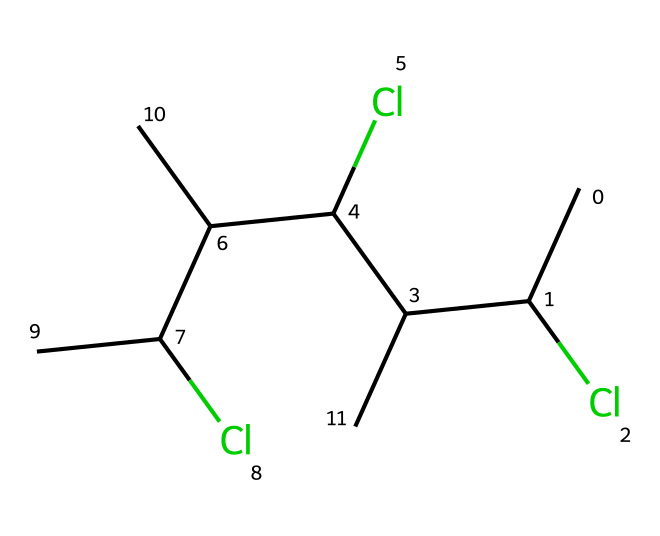How many carbon atoms are in this molecule? To determine the number of carbon atoms, we can analyze the SMILES representation, counting each 'C' that represents a carbon atom. The representation shows a total of six 'C' letters, indicating there are six carbon atoms in the molecule.
Answer: six How many chlorine atoms are present in the structure? In the SMILES representation, every 'Cl' indicates a chlorine atom. By counting the occurrences of 'Cl', we find three instances, which indicates there are three chlorine atoms in the molecule.
Answer: three What type of polymer is represented by this structure? The presence of multiple carbon atoms and chlorine substitution in the SMILES points towards it being a polyvinyl chloride. This polymer is commonly recognized for its use in construction materials and its vinyl groups result in PVC.
Answer: polyvinyl chloride How many total hydrogen atoms are associated with this molecule? To determine the total number of hydrogen atoms, we consider the valence requirements of carbon, which typically forms four bonds. Each carbon can bond with hydrogen to satisfy this; given the number of carbons and chlorines, we can deduce there are a total of eight hydrogen atoms in this structure.
Answer: eight What functional groups are indicated by the presence of chlorine in this compound? The chlorine substituents indicate that this compound contains alkyl groups that have been modified through the addition of halogen atoms. The chlorine atoms act as functional groups modifying the properties of the base polymer.
Answer: halogen functional groups 